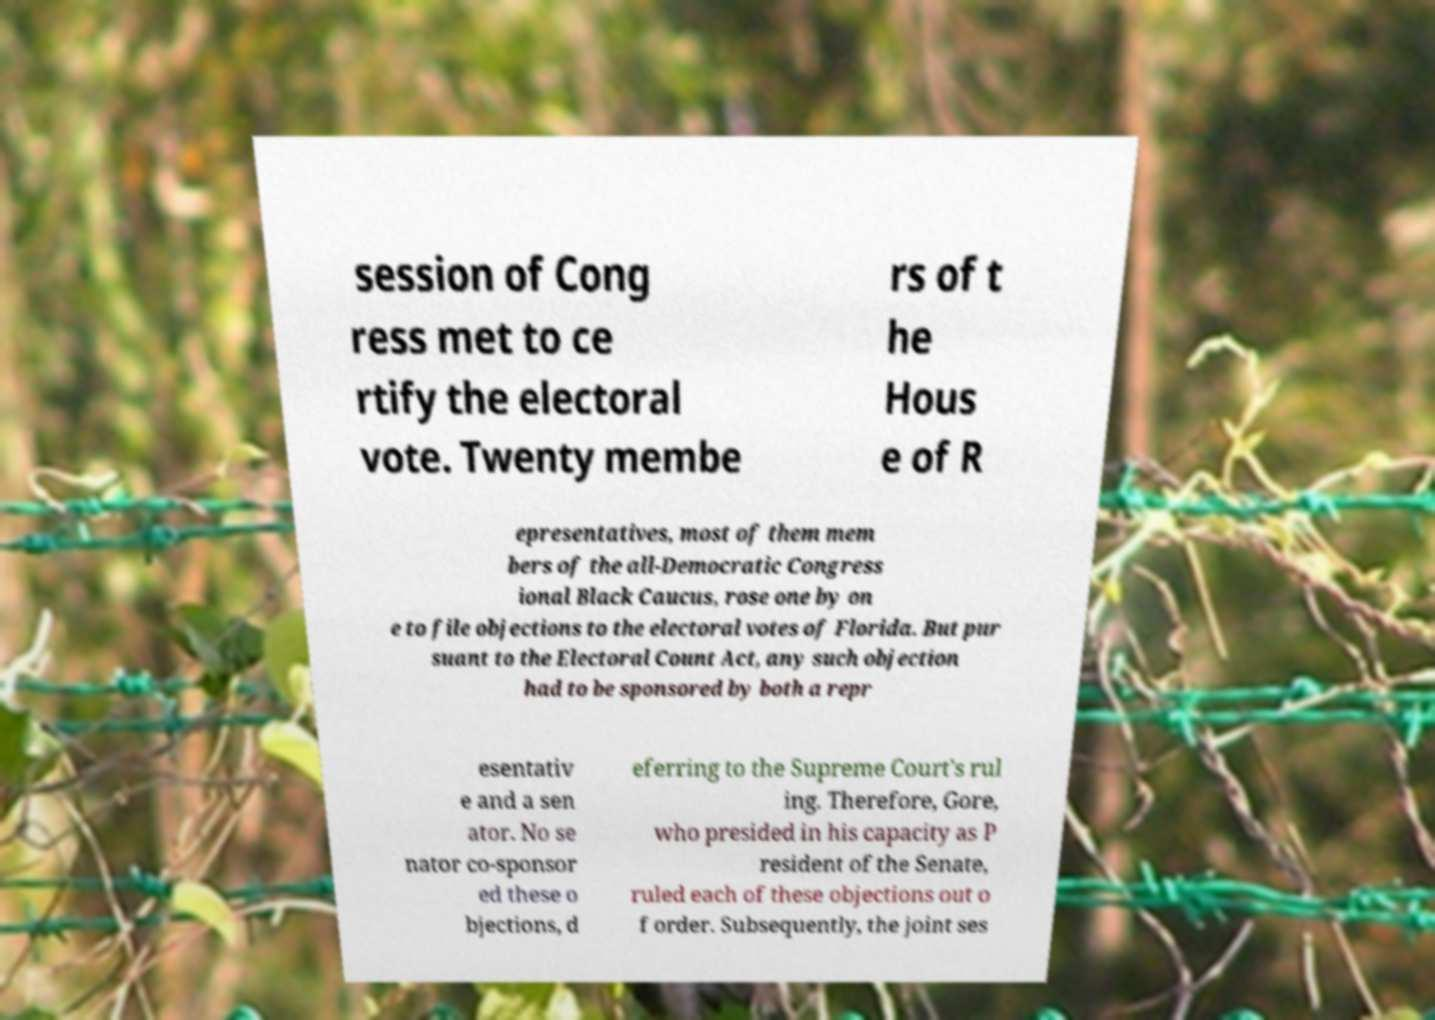Please identify and transcribe the text found in this image. session of Cong ress met to ce rtify the electoral vote. Twenty membe rs of t he Hous e of R epresentatives, most of them mem bers of the all-Democratic Congress ional Black Caucus, rose one by on e to file objections to the electoral votes of Florida. But pur suant to the Electoral Count Act, any such objection had to be sponsored by both a repr esentativ e and a sen ator. No se nator co-sponsor ed these o bjections, d eferring to the Supreme Court's rul ing. Therefore, Gore, who presided in his capacity as P resident of the Senate, ruled each of these objections out o f order. Subsequently, the joint ses 